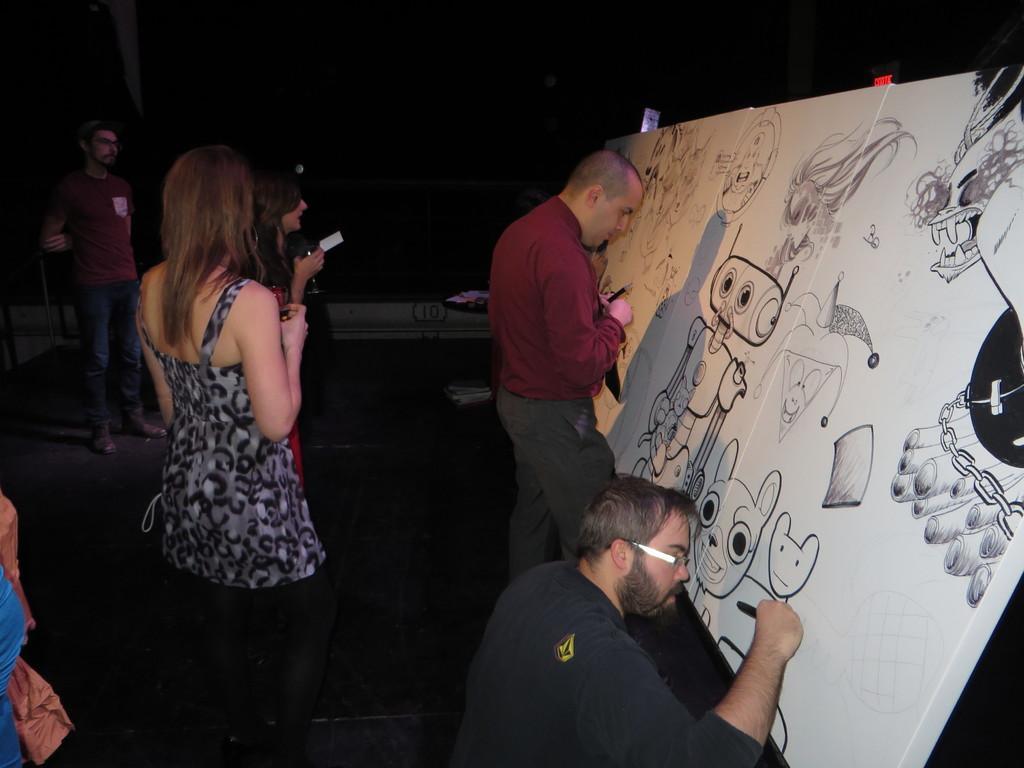Describe this image in one or two sentences. In this image we can see a group of people standing on the floor. To the right side of the image we can see a person wearing a black dress and spectacles is holding a pen in his hand and board placed on the floor. To the left side, we can see a woman holding a glass in her hand. In the background we can see a bag placed on the floor. 